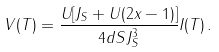<formula> <loc_0><loc_0><loc_500><loc_500>V ( T ) = \frac { U [ J _ { S } + U ( 2 x - 1 ) ] } { 4 d S J _ { S } ^ { 3 } } I ( T ) \, .</formula> 